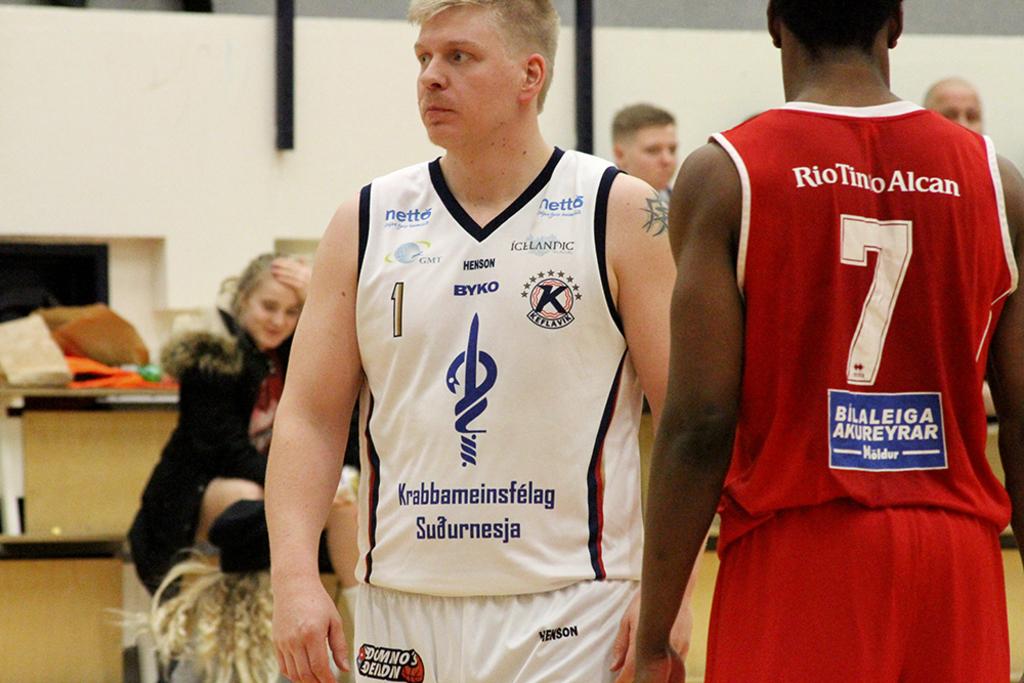What is the name of the player in jersey number 7?
Make the answer very short. Riotino alcan. What number is the player in white?
Give a very brief answer. 1. 